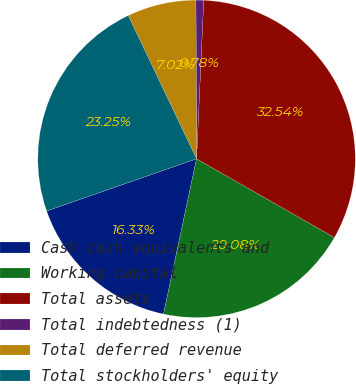Convert chart to OTSL. <chart><loc_0><loc_0><loc_500><loc_500><pie_chart><fcel>Cash cash equivalents and<fcel>Working capital<fcel>Total assets<fcel>Total indebtedness (1)<fcel>Total deferred revenue<fcel>Total stockholders' equity<nl><fcel>16.33%<fcel>20.08%<fcel>32.54%<fcel>0.78%<fcel>7.02%<fcel>23.25%<nl></chart> 